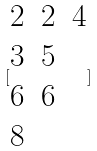Convert formula to latex. <formula><loc_0><loc_0><loc_500><loc_500>[ \begin{matrix} 2 & 2 & 4 \\ 3 & 5 \\ 6 & 6 \\ 8 \end{matrix} ]</formula> 